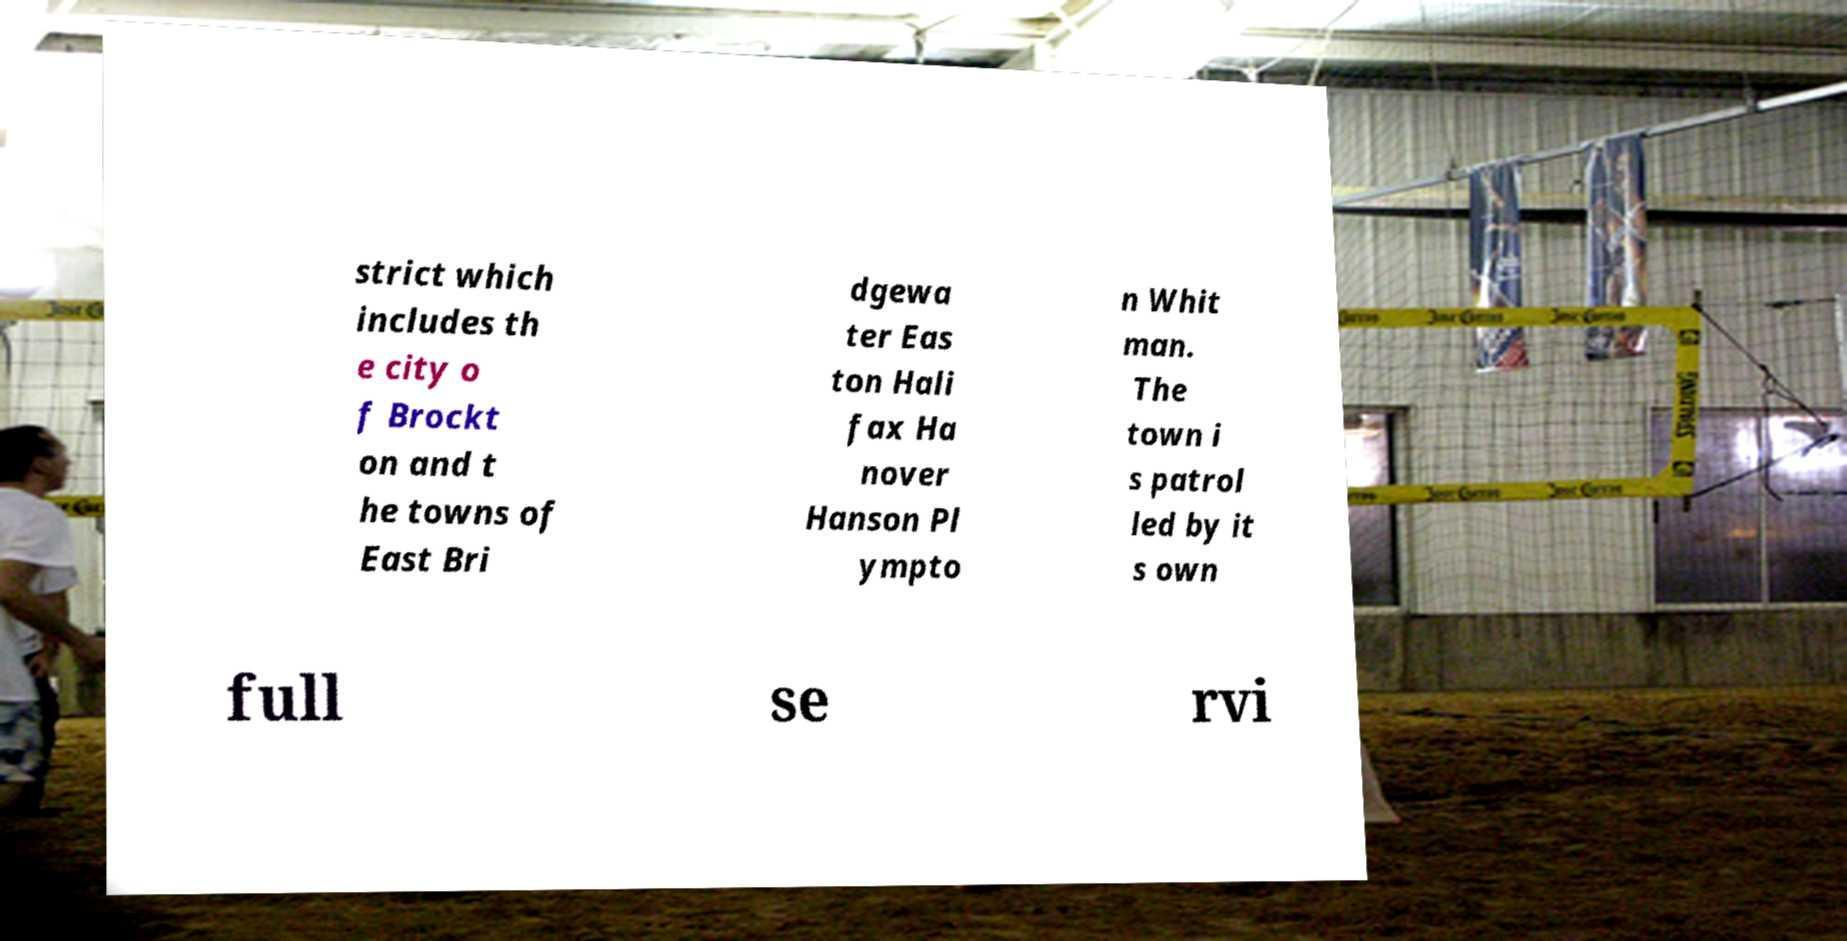There's text embedded in this image that I need extracted. Can you transcribe it verbatim? strict which includes th e city o f Brockt on and t he towns of East Bri dgewa ter Eas ton Hali fax Ha nover Hanson Pl ympto n Whit man. The town i s patrol led by it s own full se rvi 